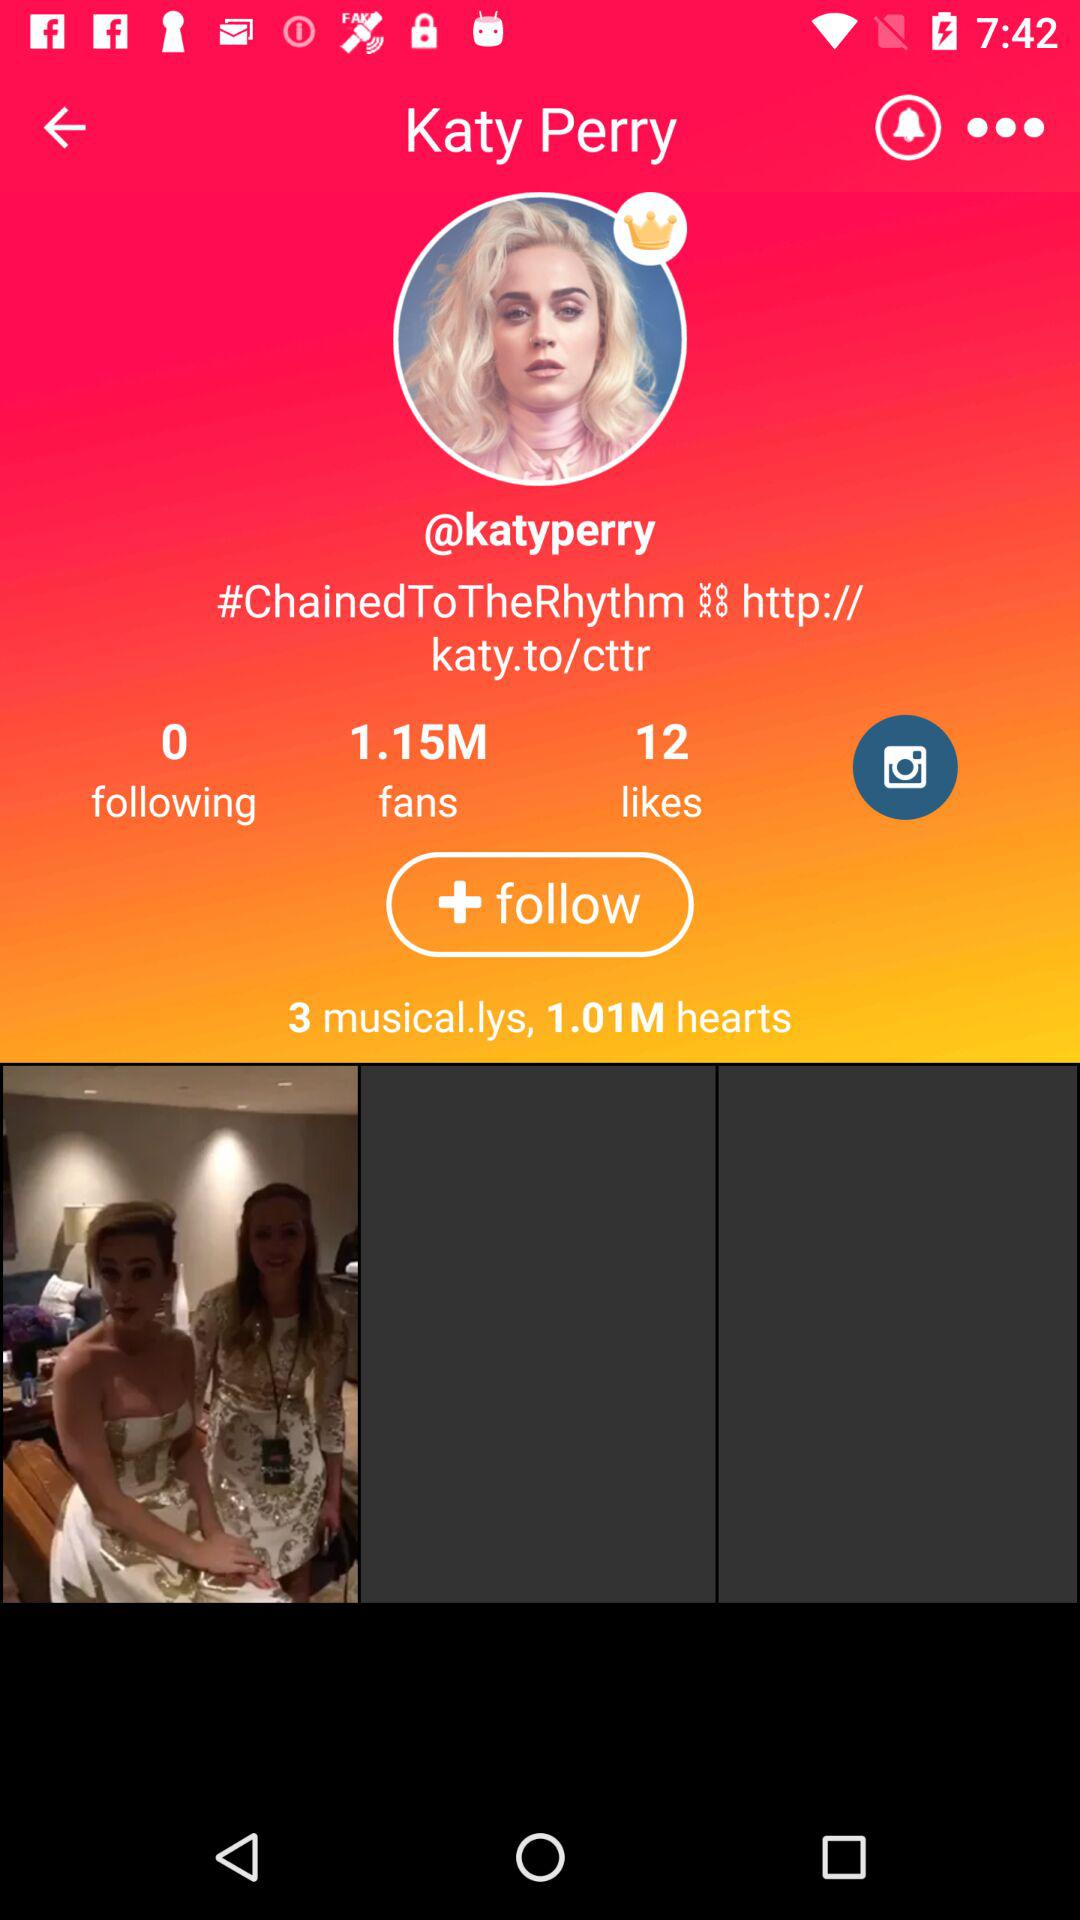What is the number of hearts? There are 1.01 million hearts. 